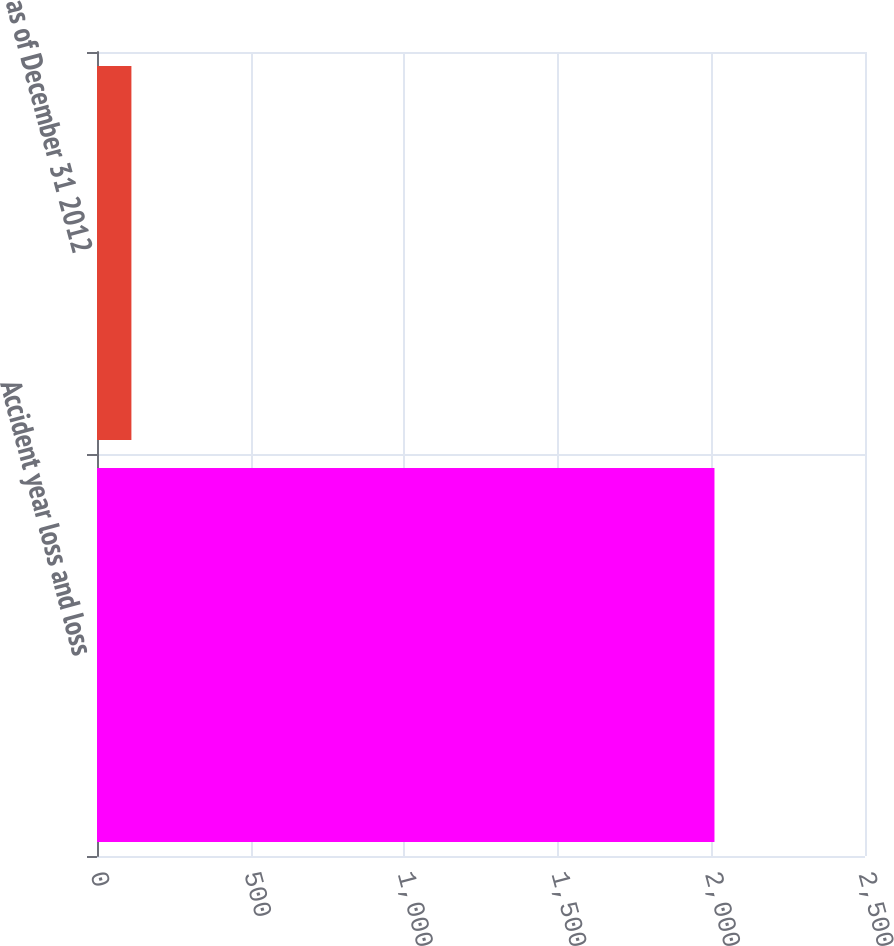Convert chart to OTSL. <chart><loc_0><loc_0><loc_500><loc_500><bar_chart><fcel>Accident year loss and loss<fcel>as of December 31 2012<nl><fcel>2010<fcel>112<nl></chart> 